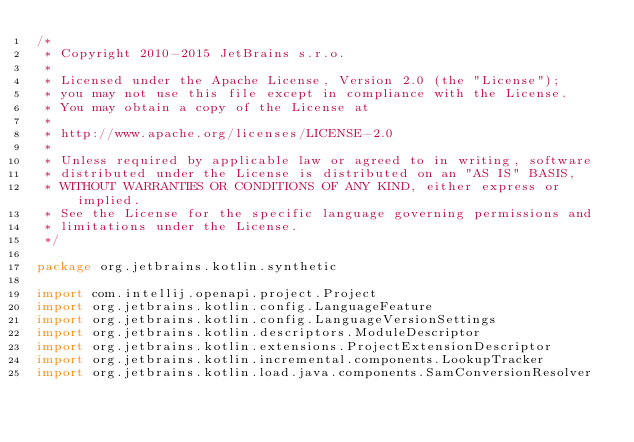<code> <loc_0><loc_0><loc_500><loc_500><_Kotlin_>/*
 * Copyright 2010-2015 JetBrains s.r.o.
 *
 * Licensed under the Apache License, Version 2.0 (the "License");
 * you may not use this file except in compliance with the License.
 * You may obtain a copy of the License at
 *
 * http://www.apache.org/licenses/LICENSE-2.0
 *
 * Unless required by applicable law or agreed to in writing, software
 * distributed under the License is distributed on an "AS IS" BASIS,
 * WITHOUT WARRANTIES OR CONDITIONS OF ANY KIND, either express or implied.
 * See the License for the specific language governing permissions and
 * limitations under the License.
 */

package org.jetbrains.kotlin.synthetic

import com.intellij.openapi.project.Project
import org.jetbrains.kotlin.config.LanguageFeature
import org.jetbrains.kotlin.config.LanguageVersionSettings
import org.jetbrains.kotlin.descriptors.ModuleDescriptor
import org.jetbrains.kotlin.extensions.ProjectExtensionDescriptor
import org.jetbrains.kotlin.incremental.components.LookupTracker
import org.jetbrains.kotlin.load.java.components.SamConversionResolver</code> 